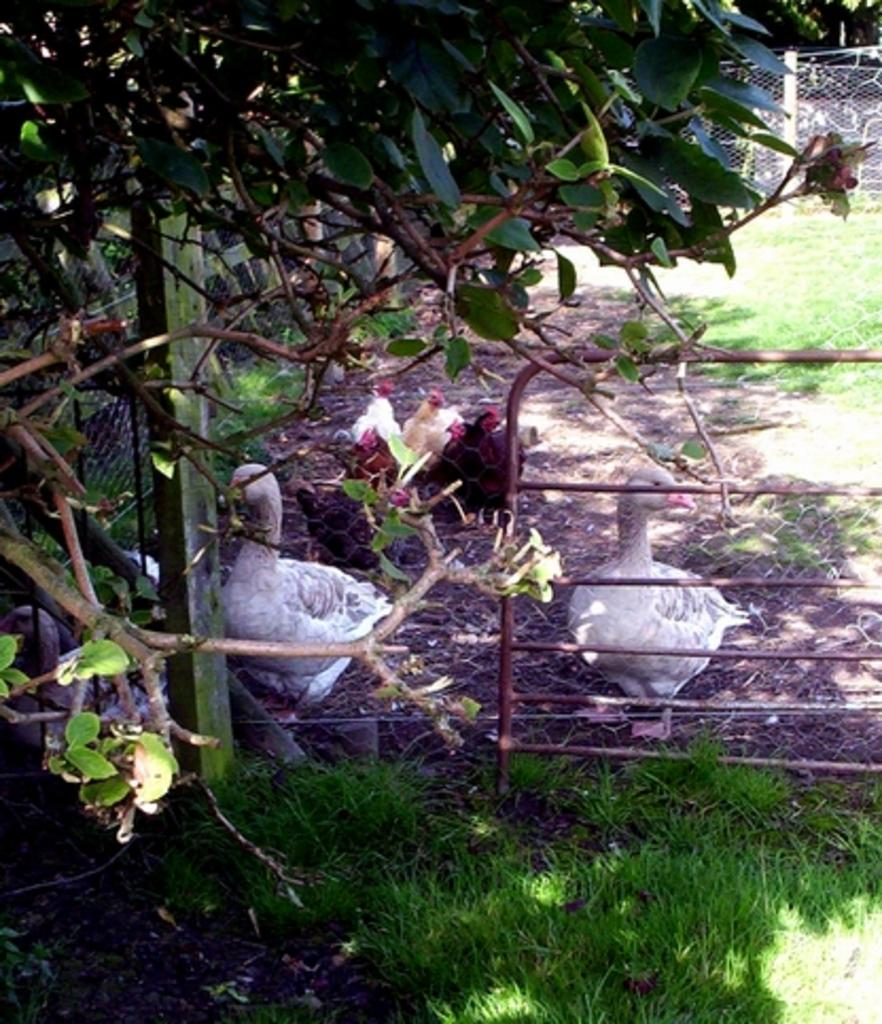What type of vegetation can be seen in the image? There are trees and grass in the image. What animals are present in the image? There are ducks and other birds in the image. What structures can be seen in the image? Metal rods and a fence are present in the image. What type of jeans is the mom wearing in the image? There is no mom or jeans present in the image. What subject is the teacher teaching in the image? There is no teacher or teaching activity present in the image. 